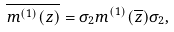Convert formula to latex. <formula><loc_0><loc_0><loc_500><loc_500>\overline { m ^ { ( 1 ) } ( z ) } = \sigma _ { 2 } m ^ { ( 1 ) } ( \overline { z } ) \sigma _ { 2 } ,</formula> 